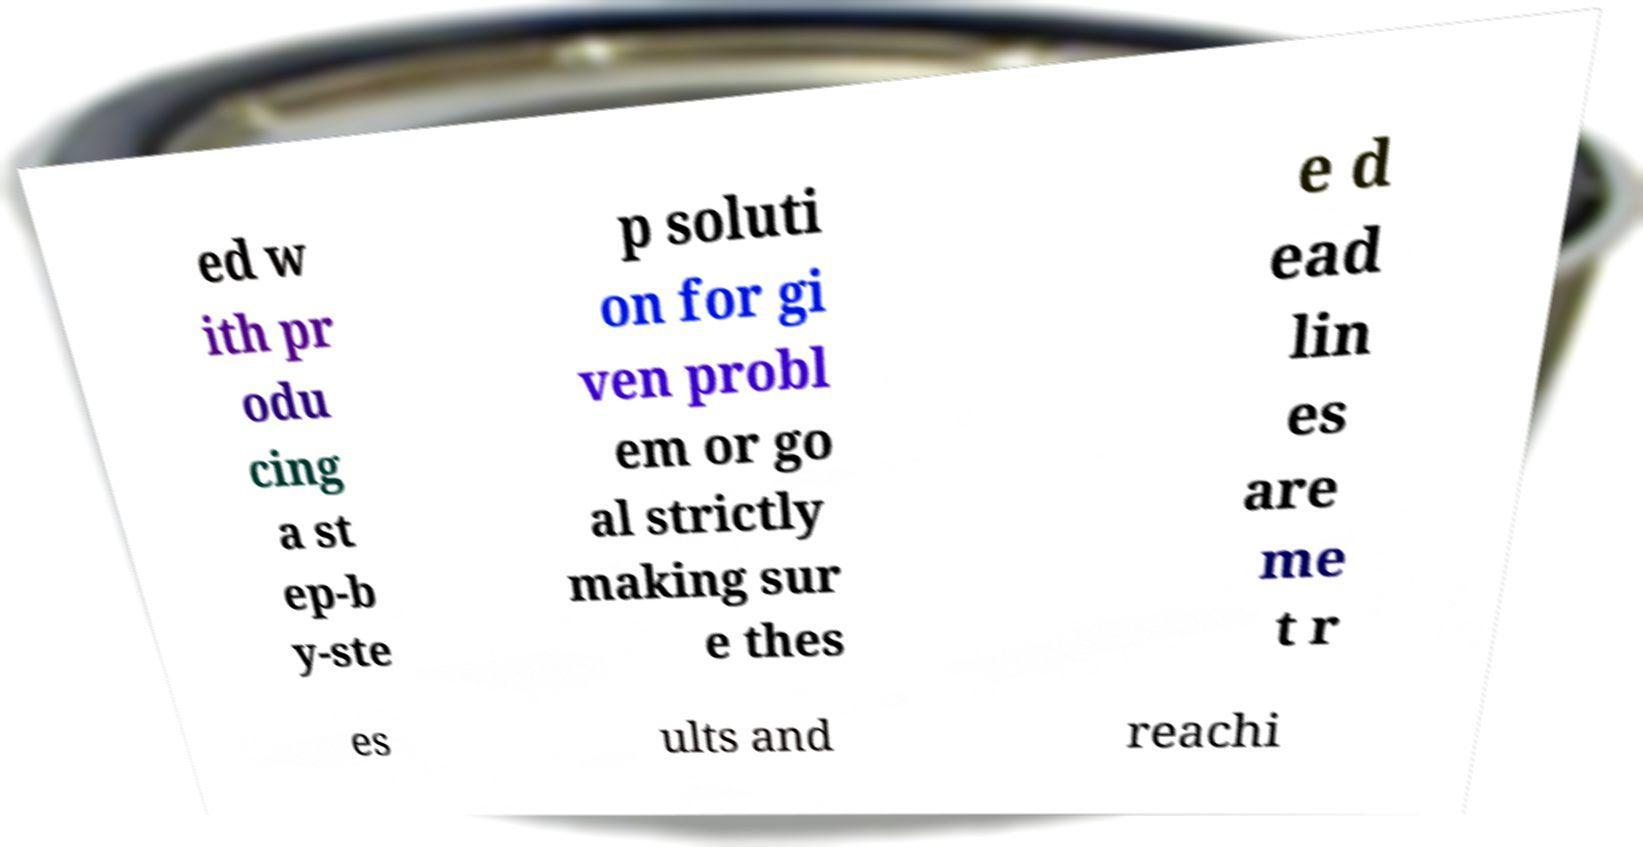Please identify and transcribe the text found in this image. ed w ith pr odu cing a st ep-b y-ste p soluti on for gi ven probl em or go al strictly making sur e thes e d ead lin es are me t r es ults and reachi 